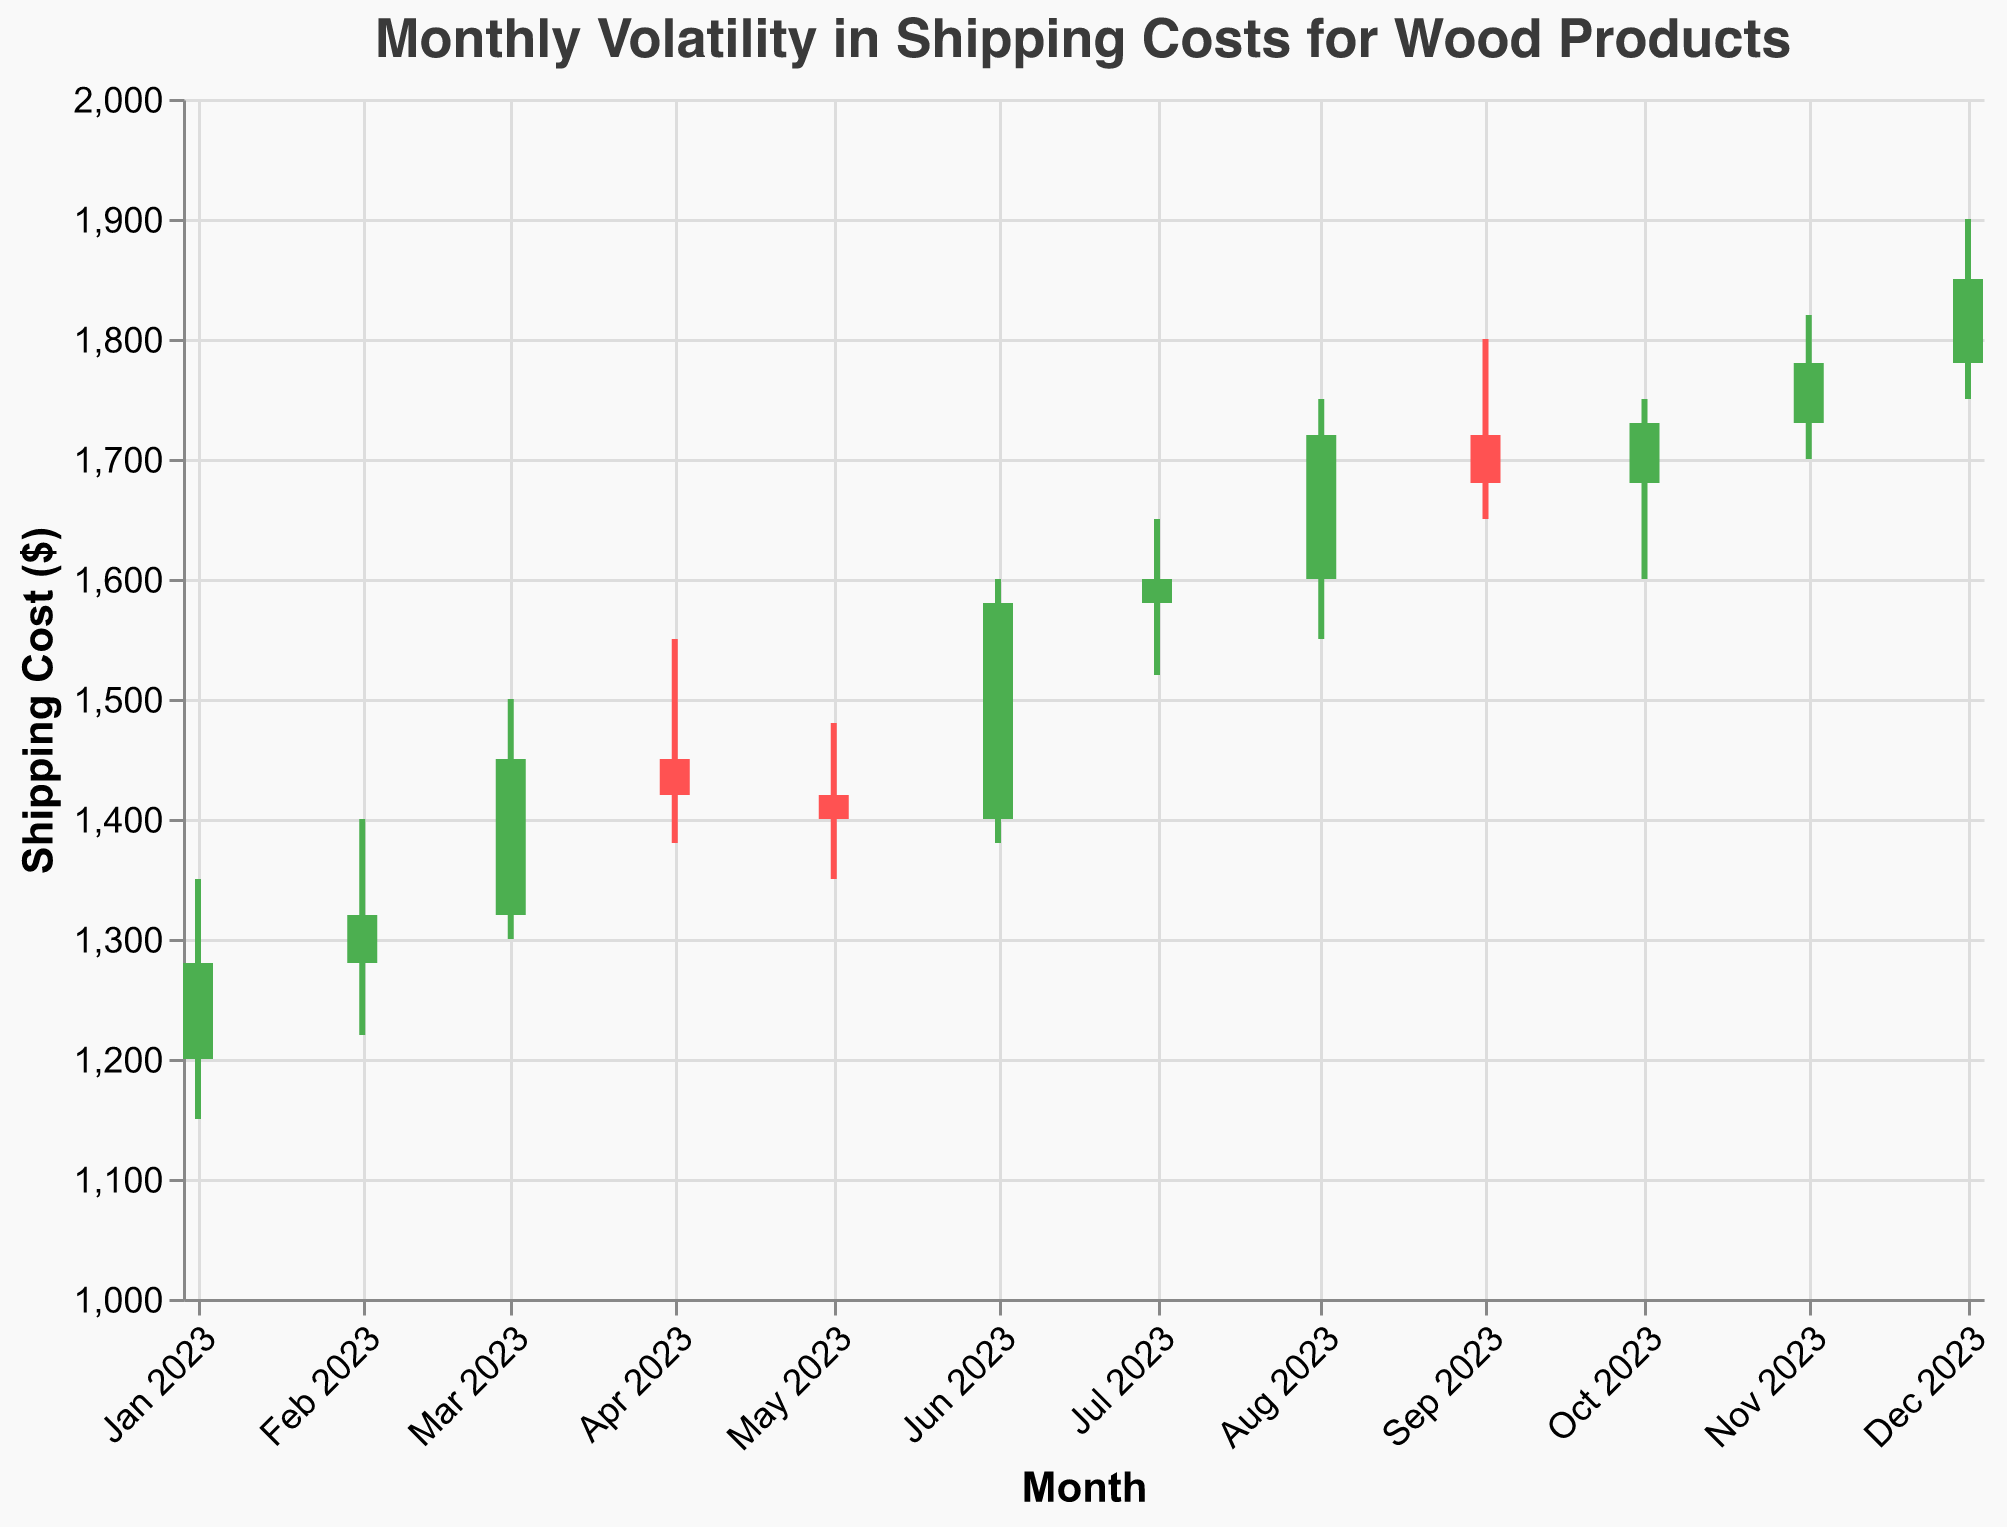How many months are displayed in the chart? The chart shows data points for each month from January 2023 to December 2023. Therefore, it includes 12 months.
Answer: 12 Which month has the highest closing shipping cost? Look for the month with the highest "Close" value. December 2023 has the highest closing cost of 1850.
Answer: December 2023 What is the range of shipping costs in March 2023? To find the range, subtract the lowest value from the highest value for March 2023. The range is 1500 (High) - 1300 (Low) = 200.
Answer: 200 During which month was the shipping cost the most volatile? Volatility can be assessed by the range between High and Low values. August 2023 has the highest range: 1750 (High) - 1550 (Low) = 200.
Answer: August 2023 What is the difference between the opening and closing shipping costs in June 2023? Subtract the June opening cost from the closing cost: 1580 (Close) - 1400 (Open) = 180.
Answer: 180 Which month showed the greatest increase in closing shipping costs from the previous month? Compare the monthly closing costs: August (1720) from July (1600) shows the largest increase of 120.
Answer: August 2023 Did any month close at a lower cost than it opened? Yes/No question. Look if there are months where Open > Close. April 2023 is an example where the closing cost (1420) is lower than the opening cost (1450).
Answer: Yes In which month did the shipping cost first surpass $1700? Look for the first month where the Highest value is above $1700. August 2023 has a high of 1750, surpassing $1700.
Answer: August 2023 How does the closing cost of November 2023 compare to its opening cost? Compare the values: November.opens at 1730 and closes at 1780. Hence, the closing cost is higher than the opening cost.
Answer: Higher 